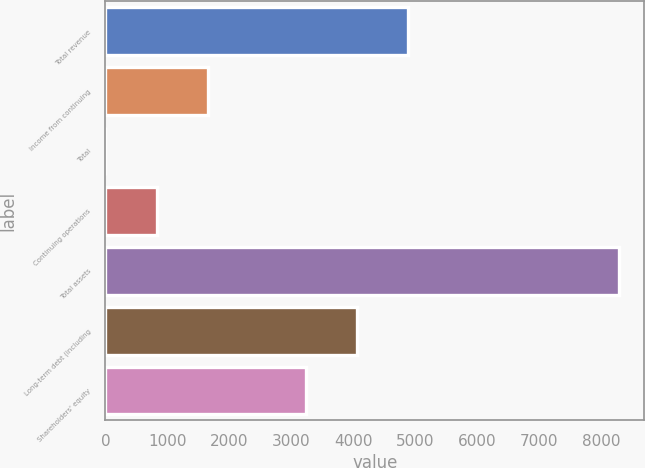Convert chart. <chart><loc_0><loc_0><loc_500><loc_500><bar_chart><fcel>Total revenue<fcel>Income from continuing<fcel>Total<fcel>Continuing operations<fcel>Total assets<fcel>Long-term debt (including<fcel>Shareholders' equity<nl><fcel>4884.86<fcel>1657.53<fcel>1.65<fcel>829.59<fcel>8281<fcel>4056.93<fcel>3229<nl></chart> 